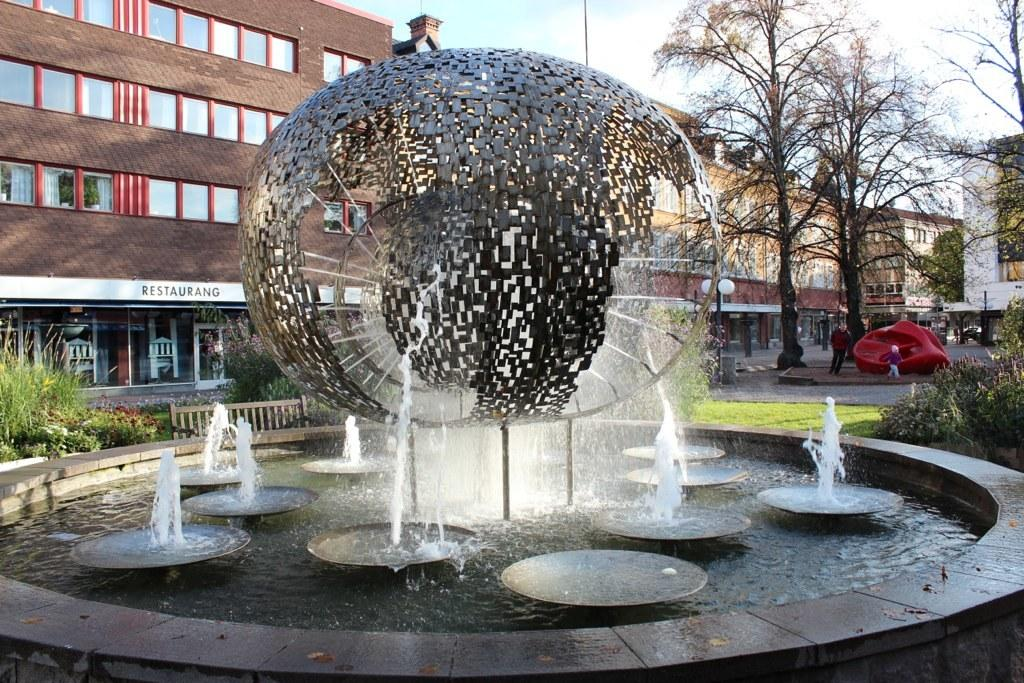What type of structures can be seen in the image? There are buildings in the image. What natural elements are present in the image? There are trees and plants in the image. Who can be seen in the image? There is a man and a kid in the image. What additional features can be found in the image? There is a water fountain and a pole light in the image. How would you describe the weather in the image? The sky is cloudy in the image. Can you tell me how many knives are being used by the man in the image? There are no knives present in the image. Is the earthquake causing the buildings to collapse in the image? There is no earthquake depicted in the image, and the buildings appear to be standing. 